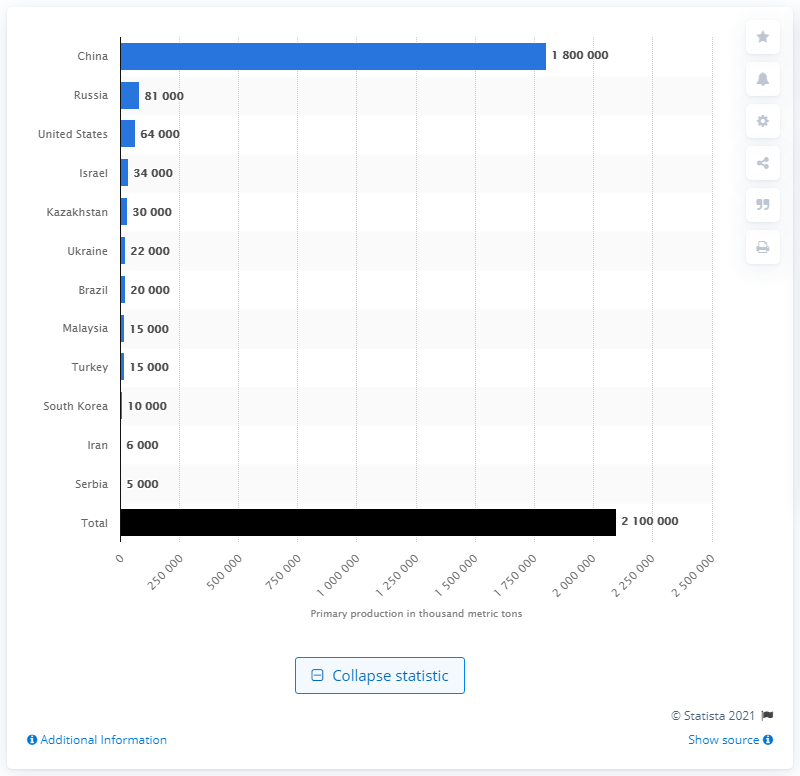List a handful of essential elements in this visual. In 2018, the primary production capacity of magnesium in China was approximately 1.8 million metric tons. Russia was the country that was in second place in terms of magnesium production in 2018. 